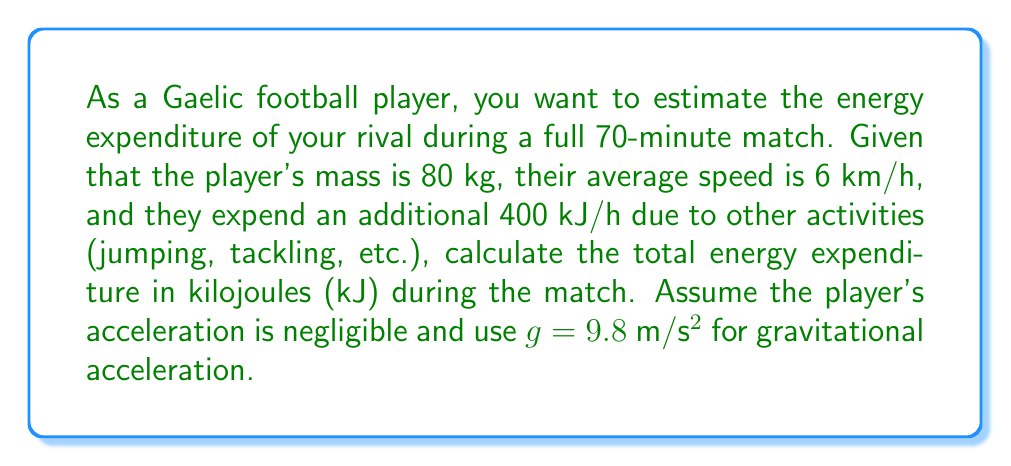Show me your answer to this math problem. To solve this problem, we need to consider two components of energy expenditure:
1. Energy spent on movement
2. Additional energy spent on other activities

Step 1: Calculate the energy spent on movement
First, we need to convert the given units:
- Match duration: 70 minutes = 1.1667 hours
- Average speed: 6 km/h = 1.667 m/s

The work done against friction (assuming constant speed) is given by:
$$W = F_f \cdot d = \mu \cdot m \cdot g \cdot v \cdot t$$

Where:
$\mu$ is the coefficient of friction (assume 0.5 for grass)
$m$ is the mass of the player (80 kg)
$g$ is the gravitational acceleration (9.8 m/s²)
$v$ is the average speed (1.667 m/s)
$t$ is the match duration (70 * 60 = 4200 seconds)

$$W = 0.5 \cdot 80 \cdot 9.8 \cdot 1.667 \cdot 4200 = 2,741,856 \text{ J} = 2,741.86 \text{ kJ}$$

Step 2: Calculate the additional energy expenditure
Additional energy = 400 kJ/h * 1.1667 h = 466.68 kJ

Step 3: Calculate the total energy expenditure
Total energy = Energy spent on movement + Additional energy
$$E_{total} = 2,741.86 \text{ kJ} + 466.68 \text{ kJ} = 3,208.54 \text{ kJ}$$
Answer: 3,208.54 kJ 